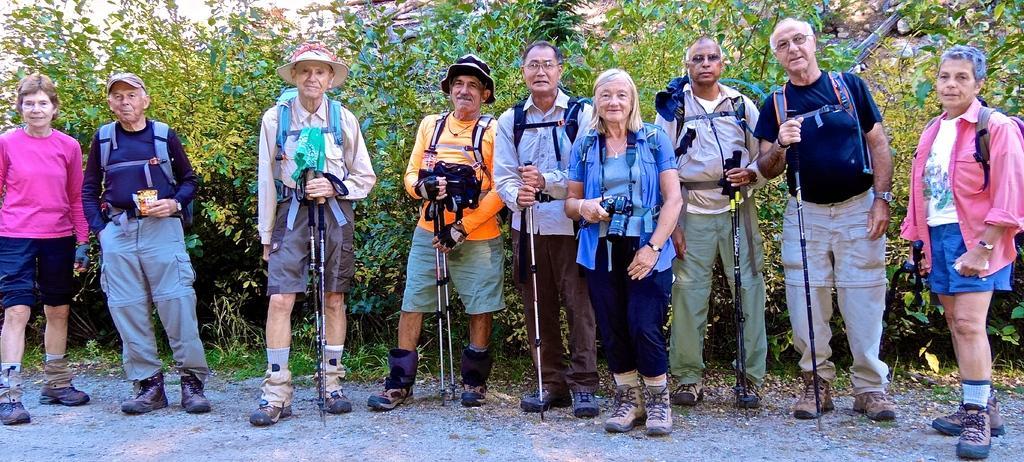Can you describe this image briefly? In this image we can see a few people standing on the ground and holding the objects, in the background, we can see some trees. 